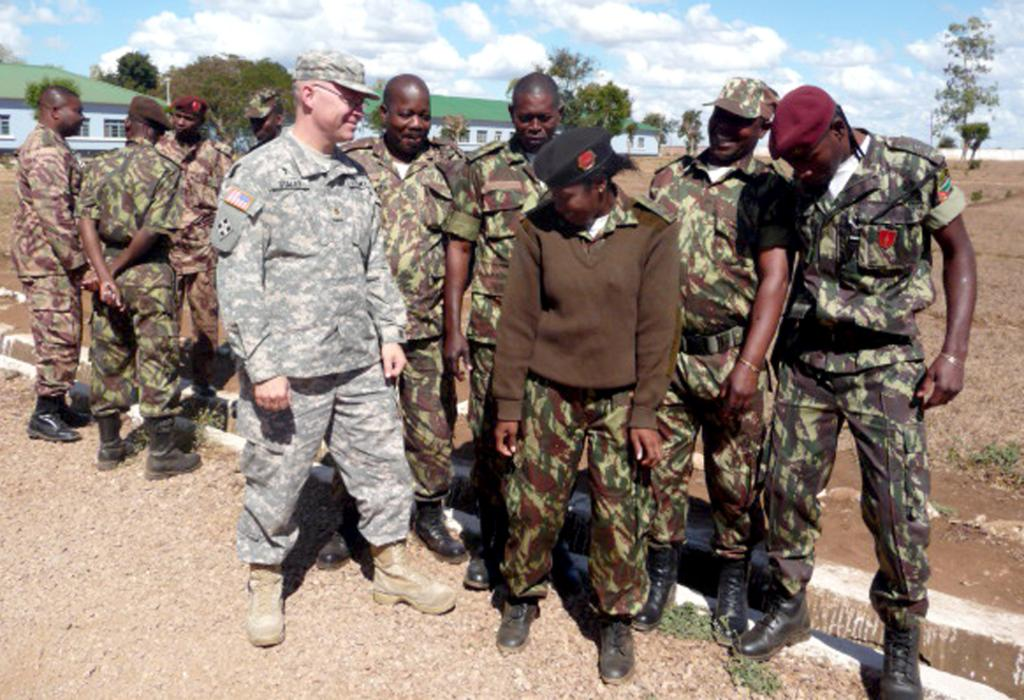What are the people in the image wearing? The people in the image are wearing army clothes. What type of footwear are the people wearing? The people are wearing shoes. Are there any accessories visible on the people in the image? Some of the people are wearing caps. What type of terrain is visible in the image? There is sand visible in the image. What type of vegetation is present in the image? There are trees in the image. What type of structures can be seen in the image? There are buildings in the image. What is the weather like in the image? The sky is cloudy in the image. What type of volleyball game is being played in the image? There is no volleyball game present in the image. How many horses are visible in the image? There are no horses visible in the image. 